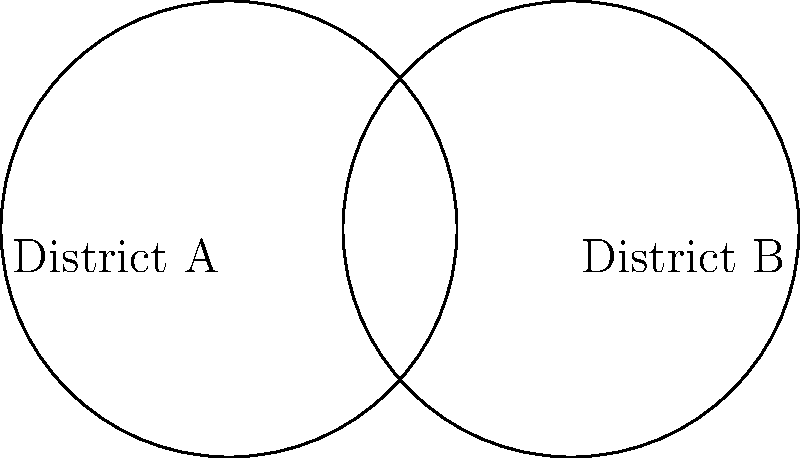In a state with two overlapping electoral districts, District A and District B, each represented by a circle with a radius of 2 units, the centers of the districts are 3 units apart. Calculate the area of the overlapping region between the two districts. Round your answer to two decimal places. To solve this problem, we'll use the formula for the area of the overlap between two circles. Let's approach this step-by-step:

1) First, we need to calculate the distance from the center of each circle to the chord that forms the boundary of the overlap. We can do this using the Pythagorean theorem:

   Let $d$ be the distance between the centers (3 units), and $r$ be the radius (2 units).
   $$x^2 + (\frac{d}{2})^2 = r^2$$
   $$x^2 + (\frac{3}{2})^2 = 2^2$$
   $$x^2 = 4 - \frac{9}{4} = \frac{7}{4}$$
   $$x = \sqrt{\frac{7}{4}} \approx 1.32$$

2) Now we can calculate the angle $\theta$ (in radians) at the center of each circle:
   $$\theta = 2 \arccos(\frac{3}{4}) \approx 2.0944$$

3) The area of the sector formed in each circle is:
   $$A_{sector} = \frac{1}{2}r^2\theta = \frac{1}{2} \cdot 2^2 \cdot 2.0944 = 4.1888$$

4) The area of the triangle formed in each circle is:
   $$A_{triangle} = \frac{1}{2} \cdot 3 \cdot 1.32 = 1.98$$

5) The area of the overlap for each circle is the difference between these:
   $$A_{overlap} = A_{sector} - A_{triangle} = 4.1888 - 1.98 = 2.2088$$

6) The total overlapping area is twice this:
   $$A_{total} = 2 \cdot 2.2088 = 4.4176$$

Rounding to two decimal places, we get 4.42 square units.
Answer: 4.42 square units 